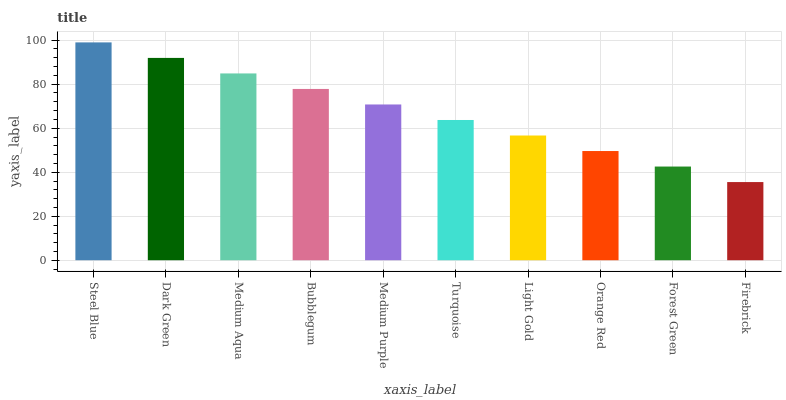Is Firebrick the minimum?
Answer yes or no. Yes. Is Steel Blue the maximum?
Answer yes or no. Yes. Is Dark Green the minimum?
Answer yes or no. No. Is Dark Green the maximum?
Answer yes or no. No. Is Steel Blue greater than Dark Green?
Answer yes or no. Yes. Is Dark Green less than Steel Blue?
Answer yes or no. Yes. Is Dark Green greater than Steel Blue?
Answer yes or no. No. Is Steel Blue less than Dark Green?
Answer yes or no. No. Is Medium Purple the high median?
Answer yes or no. Yes. Is Turquoise the low median?
Answer yes or no. Yes. Is Dark Green the high median?
Answer yes or no. No. Is Orange Red the low median?
Answer yes or no. No. 